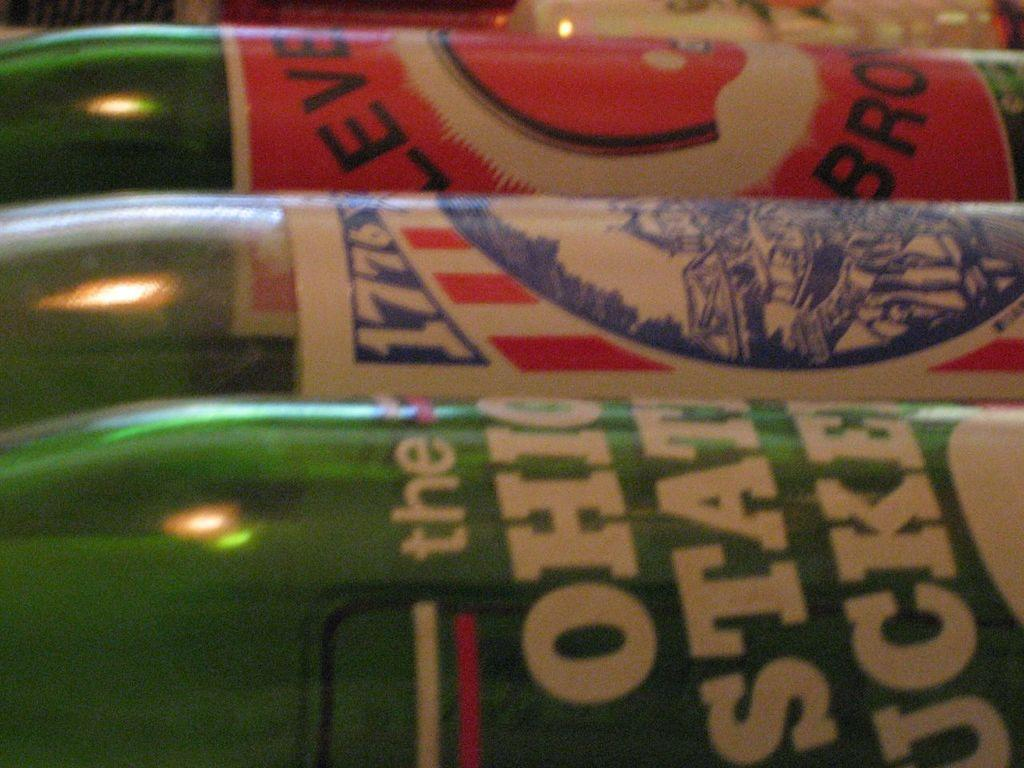<image>
Share a concise interpretation of the image provided. Multiple green bottles including one of the Ohio State Buckeyes. 